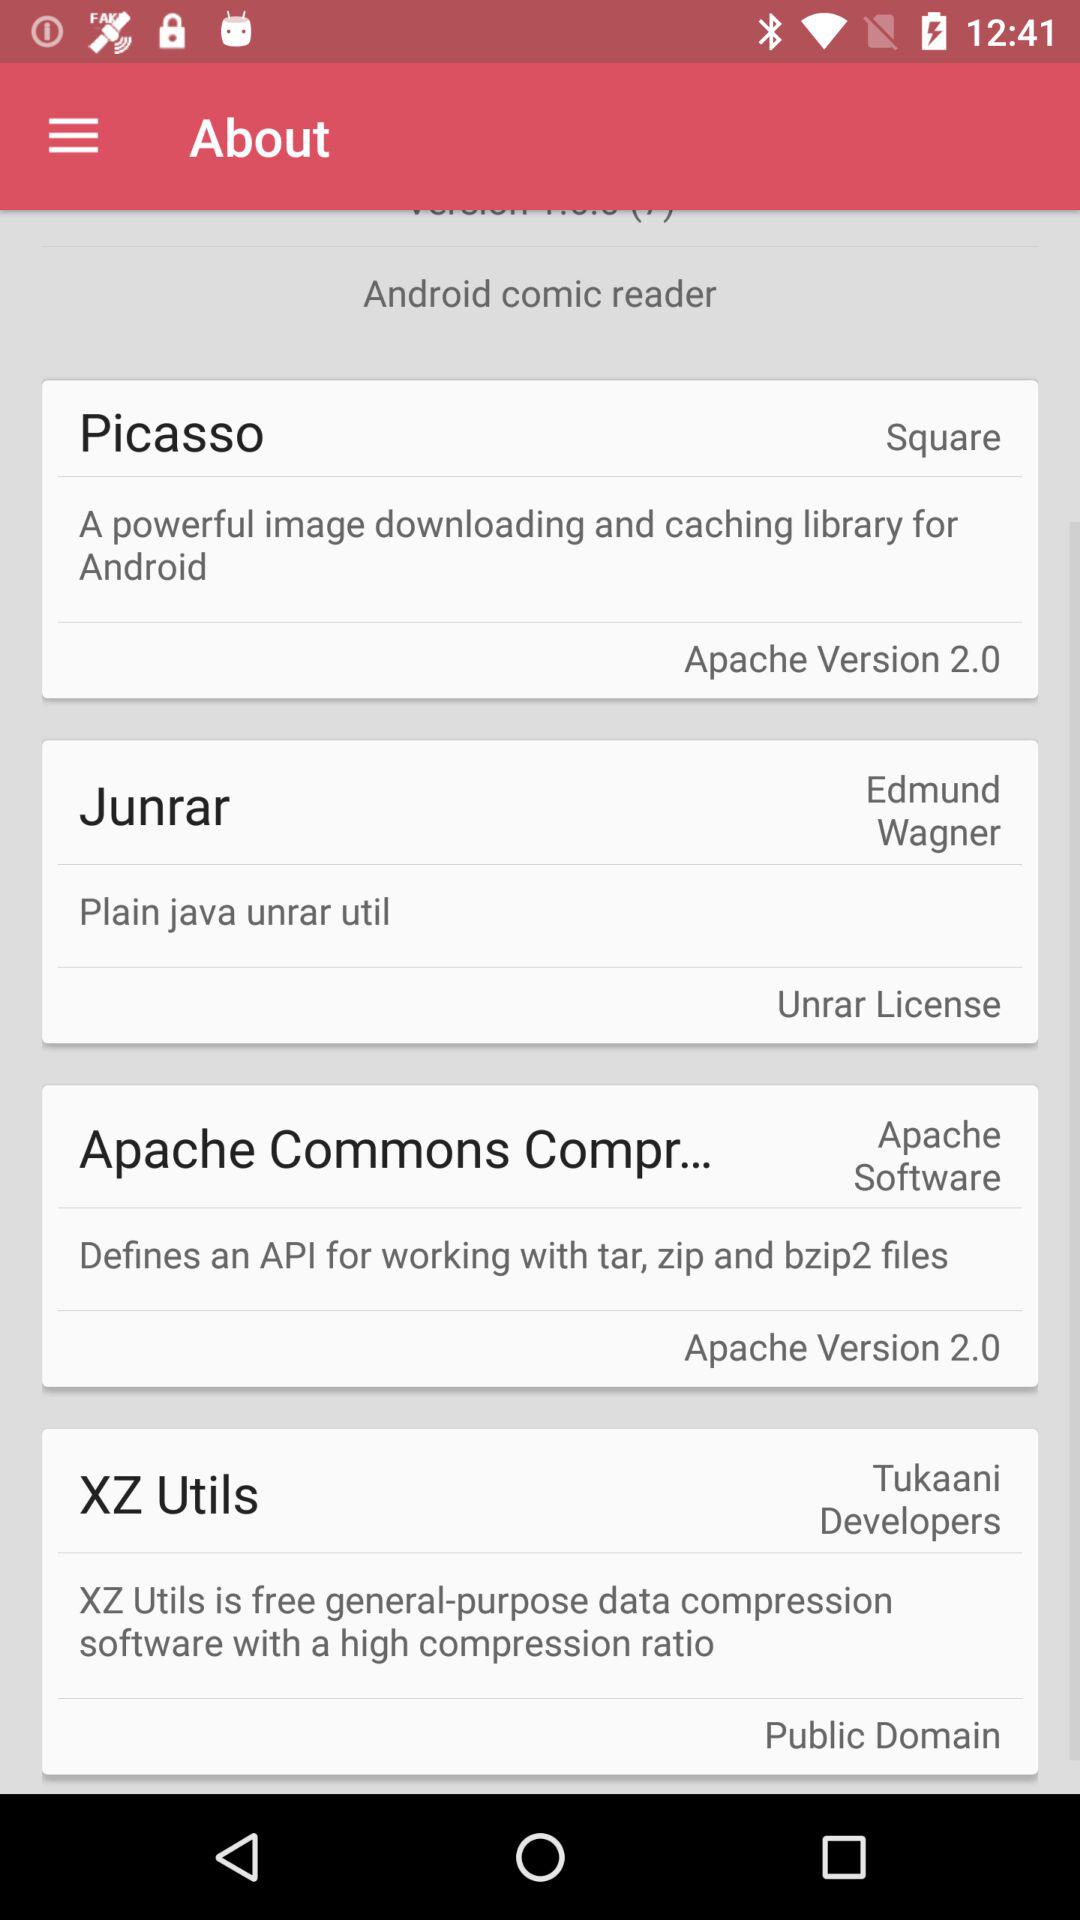Which item is selected in the menu? The selected item is "About". 